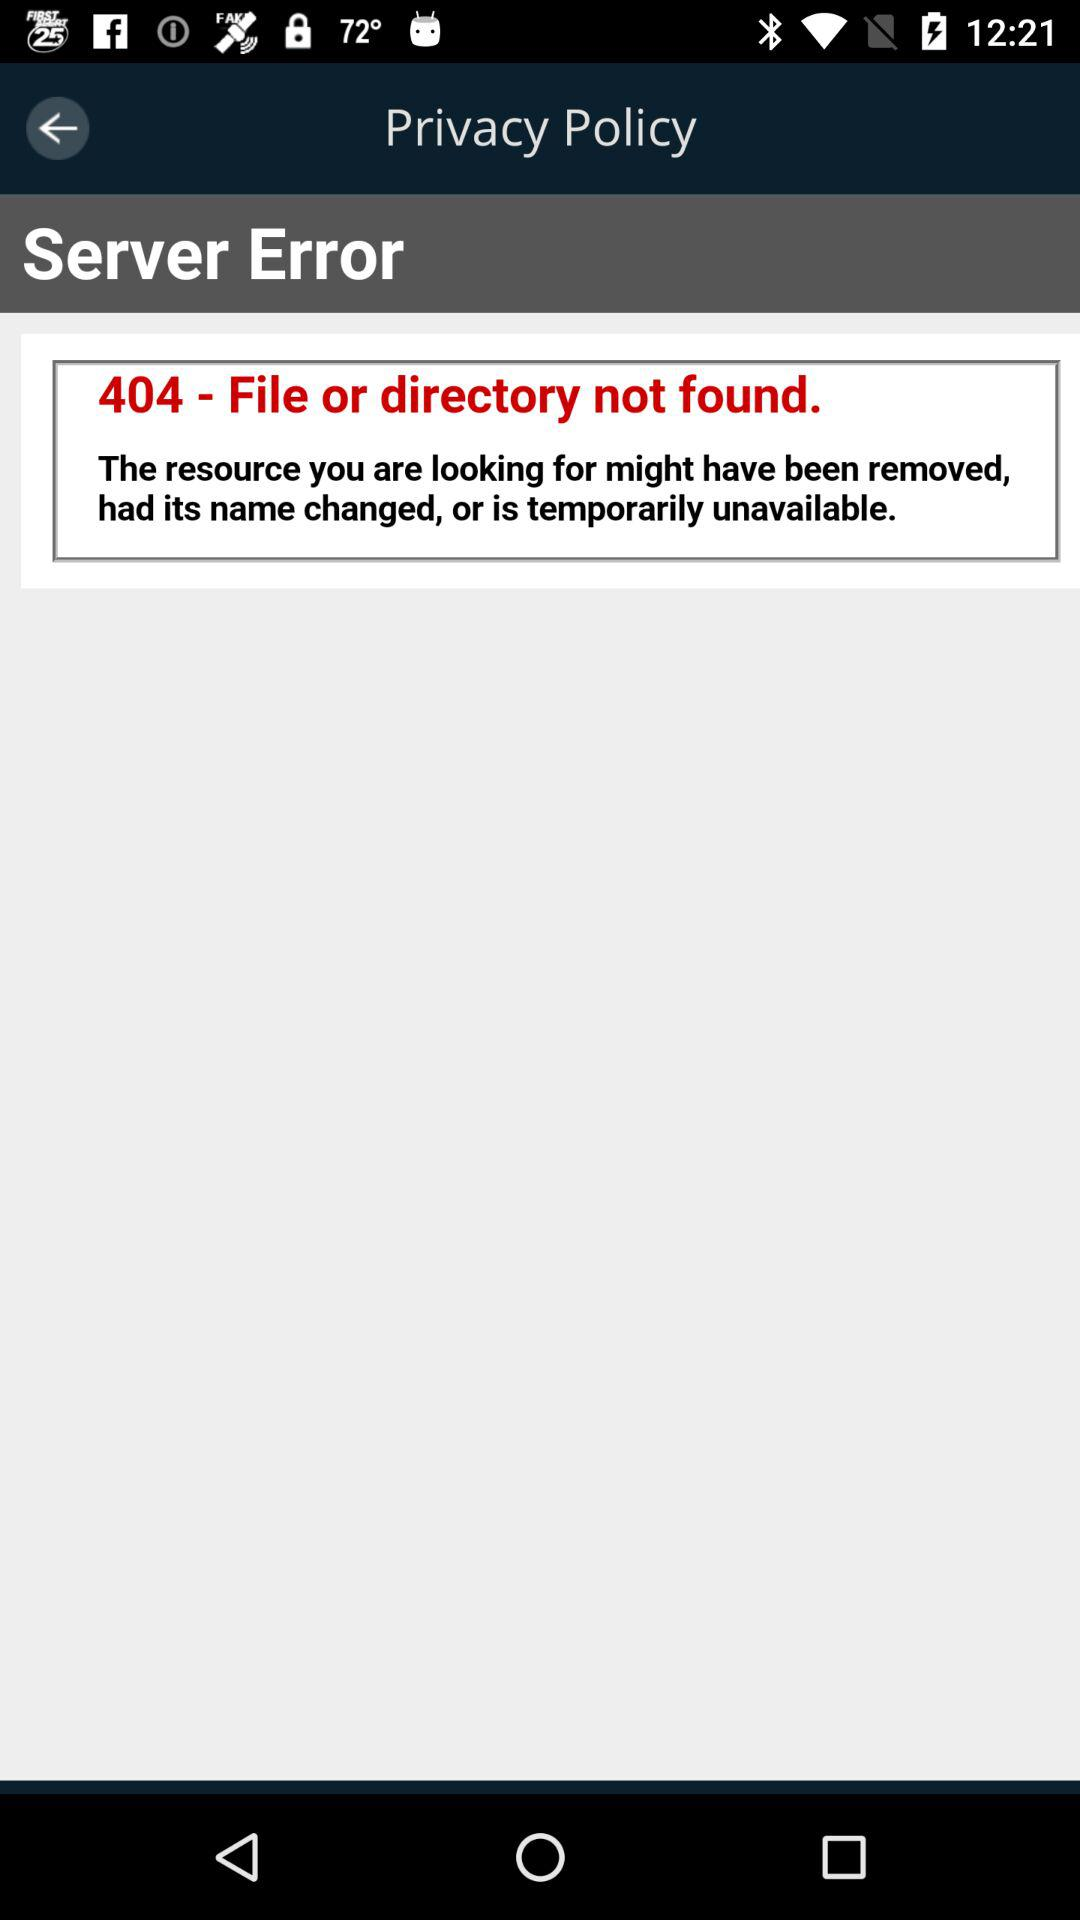What entity has changed in the resource? The resource's name has changed. 